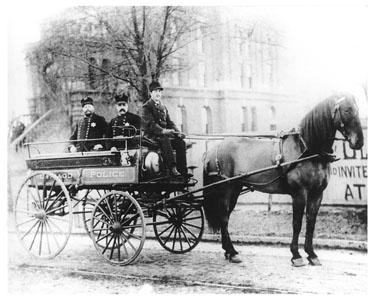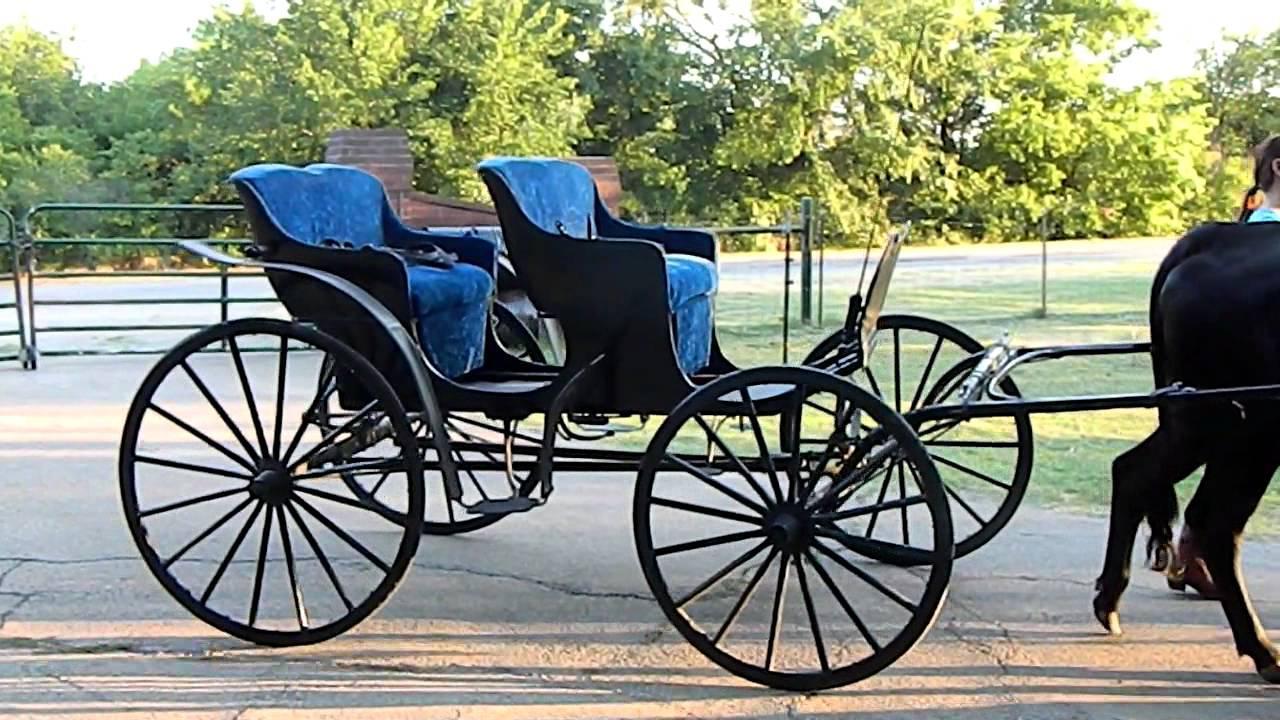The first image is the image on the left, the second image is the image on the right. Examine the images to the left and right. Is the description "In one of the images there is  a carriage with two horses hitched to it." accurate? Answer yes or no. No. 